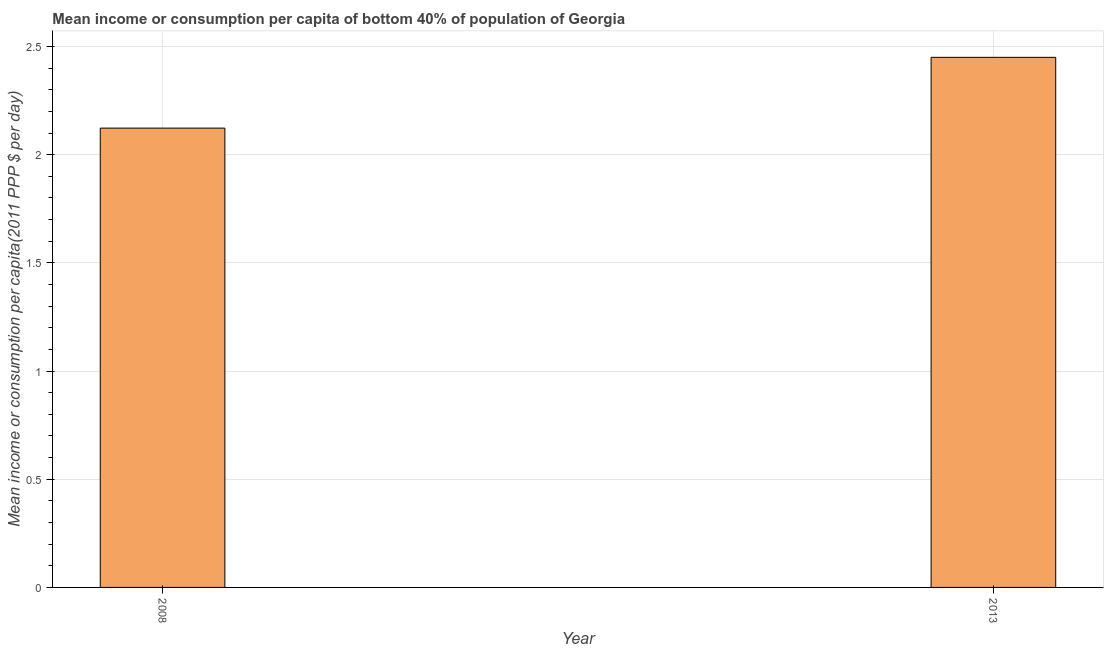Does the graph contain grids?
Your answer should be compact. Yes. What is the title of the graph?
Your answer should be compact. Mean income or consumption per capita of bottom 40% of population of Georgia. What is the label or title of the X-axis?
Your response must be concise. Year. What is the label or title of the Y-axis?
Offer a very short reply. Mean income or consumption per capita(2011 PPP $ per day). What is the mean income or consumption in 2008?
Keep it short and to the point. 2.12. Across all years, what is the maximum mean income or consumption?
Ensure brevity in your answer.  2.45. Across all years, what is the minimum mean income or consumption?
Ensure brevity in your answer.  2.12. In which year was the mean income or consumption maximum?
Your answer should be compact. 2013. What is the sum of the mean income or consumption?
Provide a short and direct response. 4.57. What is the difference between the mean income or consumption in 2008 and 2013?
Your response must be concise. -0.33. What is the average mean income or consumption per year?
Provide a succinct answer. 2.29. What is the median mean income or consumption?
Provide a succinct answer. 2.29. Do a majority of the years between 2008 and 2013 (inclusive) have mean income or consumption greater than 0.5 $?
Make the answer very short. Yes. What is the ratio of the mean income or consumption in 2008 to that in 2013?
Offer a very short reply. 0.87. In how many years, is the mean income or consumption greater than the average mean income or consumption taken over all years?
Your answer should be compact. 1. How many years are there in the graph?
Your response must be concise. 2. What is the difference between two consecutive major ticks on the Y-axis?
Your response must be concise. 0.5. Are the values on the major ticks of Y-axis written in scientific E-notation?
Provide a short and direct response. No. What is the Mean income or consumption per capita(2011 PPP $ per day) in 2008?
Keep it short and to the point. 2.12. What is the Mean income or consumption per capita(2011 PPP $ per day) of 2013?
Offer a terse response. 2.45. What is the difference between the Mean income or consumption per capita(2011 PPP $ per day) in 2008 and 2013?
Keep it short and to the point. -0.33. What is the ratio of the Mean income or consumption per capita(2011 PPP $ per day) in 2008 to that in 2013?
Keep it short and to the point. 0.87. 